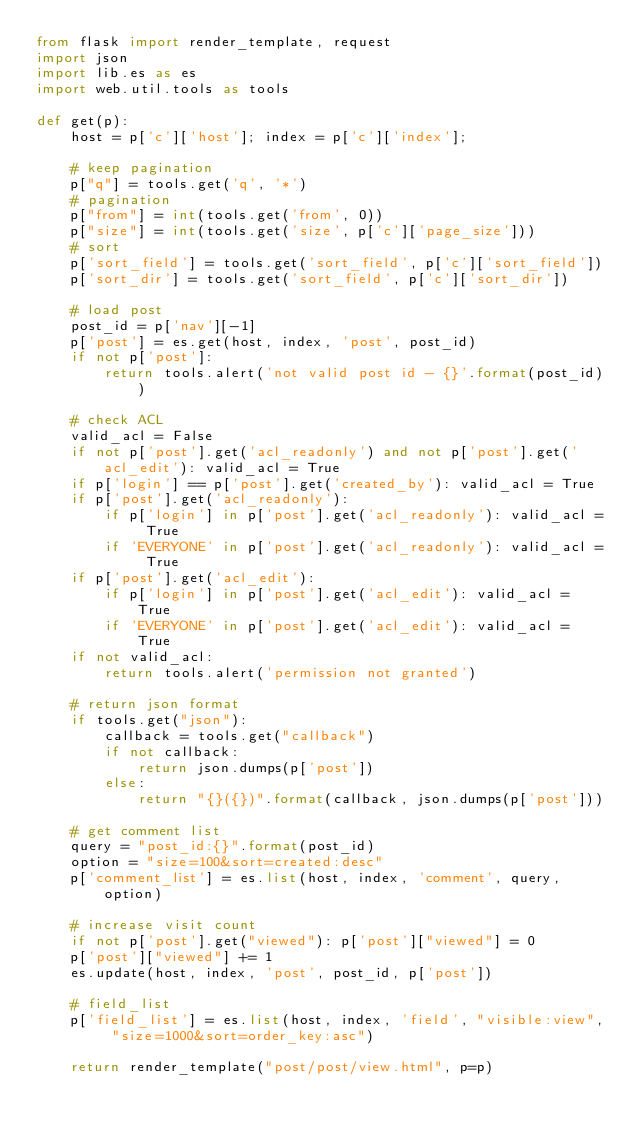<code> <loc_0><loc_0><loc_500><loc_500><_Python_>from flask import render_template, request
import json
import lib.es as es
import web.util.tools as tools

def get(p):
    host = p['c']['host']; index = p['c']['index'];

    # keep pagination
    p["q"] = tools.get('q', '*')
    # pagination
    p["from"] = int(tools.get('from', 0))
    p["size"] = int(tools.get('size', p['c']['page_size']))
    # sort
    p['sort_field'] = tools.get('sort_field', p['c']['sort_field'])
    p['sort_dir'] = tools.get('sort_field', p['c']['sort_dir'])

    # load post
    post_id = p['nav'][-1]
    p['post'] = es.get(host, index, 'post', post_id)
    if not p['post']:
        return tools.alert('not valid post id - {}'.format(post_id))

    # check ACL
    valid_acl = False
    if not p['post'].get('acl_readonly') and not p['post'].get('acl_edit'): valid_acl = True
    if p['login'] == p['post'].get('created_by'): valid_acl = True
    if p['post'].get('acl_readonly'):
        if p['login'] in p['post'].get('acl_readonly'): valid_acl = True
        if 'EVERYONE' in p['post'].get('acl_readonly'): valid_acl = True
    if p['post'].get('acl_edit'):
        if p['login'] in p['post'].get('acl_edit'): valid_acl = True
        if 'EVERYONE' in p['post'].get('acl_edit'): valid_acl = True
    if not valid_acl:
        return tools.alert('permission not granted')

    # return json format
    if tools.get("json"):
        callback = tools.get("callback")
        if not callback:
            return json.dumps(p['post'])
        else:
            return "{}({})".format(callback, json.dumps(p['post']))

    # get comment list
    query = "post_id:{}".format(post_id)
    option = "size=100&sort=created:desc"
    p['comment_list'] = es.list(host, index, 'comment', query, option)

    # increase visit count
    if not p['post'].get("viewed"): p['post']["viewed"] = 0
    p['post']["viewed"] += 1
    es.update(host, index, 'post', post_id, p['post'])

    # field_list
    p['field_list'] = es.list(host, index, 'field', "visible:view", "size=1000&sort=order_key:asc")

    return render_template("post/post/view.html", p=p)
</code> 